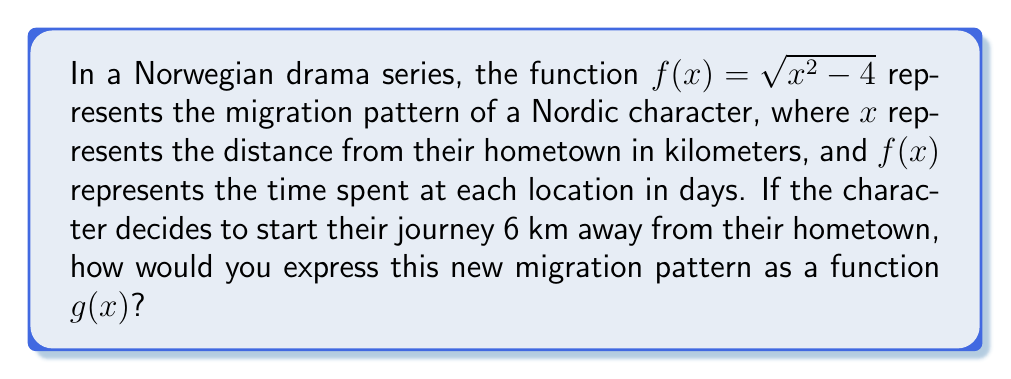Show me your answer to this math problem. To solve this problem, we need to translate the original function $f(x)$ horizontally to the right by 6 units. This is because the character is starting their journey 6 km away from their hometown, which shifts the entire function to the right on the x-axis.

Steps to translate the function:

1. The general form for a horizontal translation is:
   $g(x) = f(x - h)$, where $h$ is the number of units to shift right (positive) or left (negative).

2. In this case, we're shifting 6 units to the right, so $h = 6$.

3. Substitute this into the general form:
   $g(x) = f(x - 6)$

4. Now, replace $f$ with the original function:
   $g(x) = \sqrt{(x-6)^2 - 4}$

5. Simplify the expression inside the parentheses:
   $g(x) = \sqrt{x^2 - 12x + 36 - 4}$
   $g(x) = \sqrt{x^2 - 12x + 32}$

This new function $g(x)$ represents the translated migration pattern of the Nordic character, starting 6 km away from their hometown.
Answer: $g(x) = \sqrt{x^2 - 12x + 32}$ 